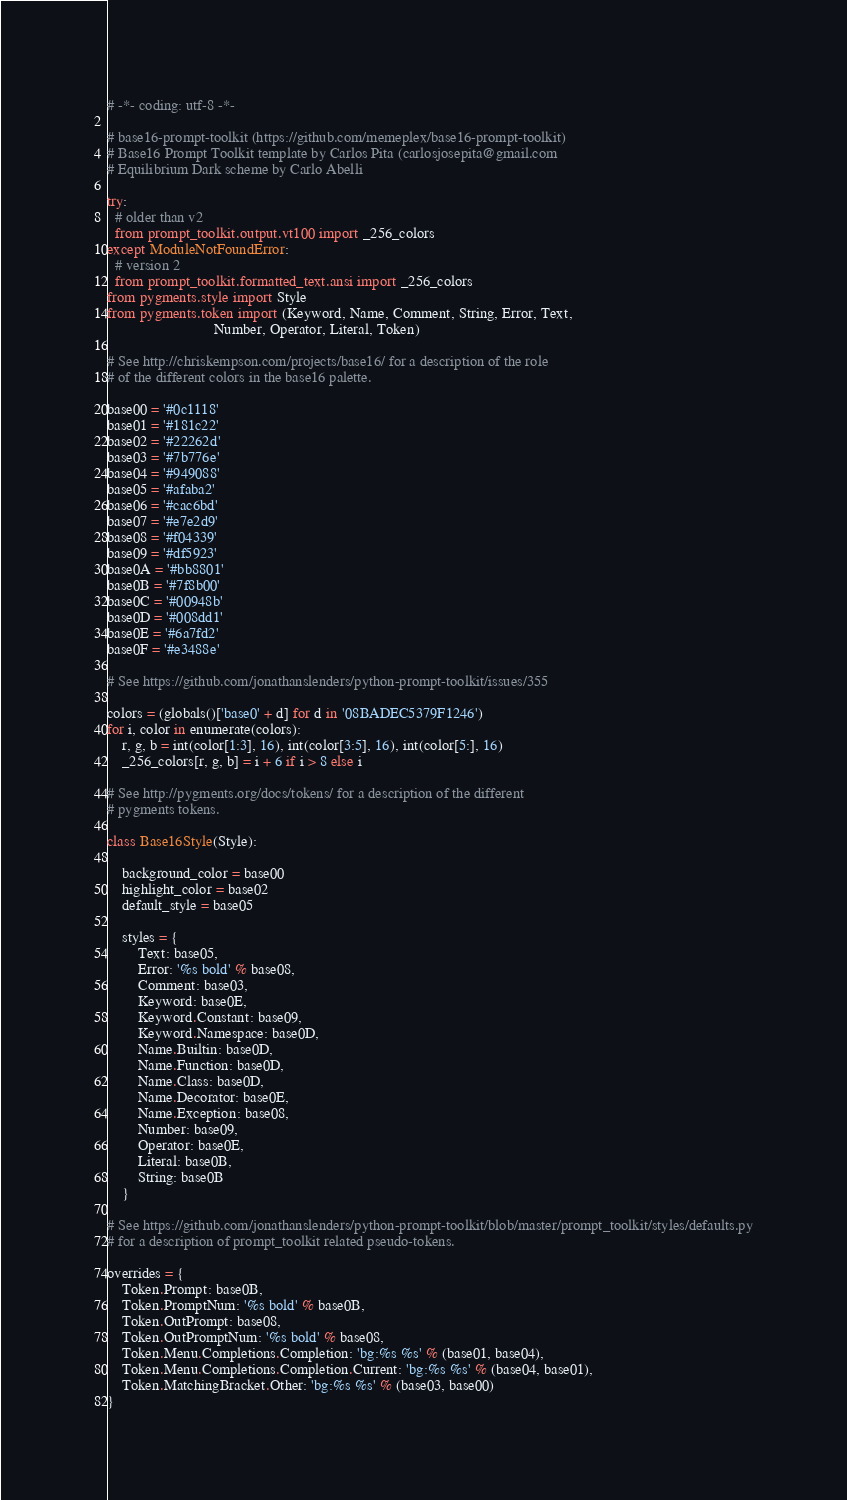<code> <loc_0><loc_0><loc_500><loc_500><_Python_># -*- coding: utf-8 -*-

# base16-prompt-toolkit (https://github.com/memeplex/base16-prompt-toolkit)
# Base16 Prompt Toolkit template by Carlos Pita (carlosjosepita@gmail.com
# Equilibrium Dark scheme by Carlo Abelli

try:
  # older than v2
  from prompt_toolkit.output.vt100 import _256_colors
except ModuleNotFoundError:
  # version 2
  from prompt_toolkit.formatted_text.ansi import _256_colors
from pygments.style import Style
from pygments.token import (Keyword, Name, Comment, String, Error, Text,
                            Number, Operator, Literal, Token)

# See http://chriskempson.com/projects/base16/ for a description of the role
# of the different colors in the base16 palette.

base00 = '#0c1118'
base01 = '#181c22'
base02 = '#22262d'
base03 = '#7b776e'
base04 = '#949088'
base05 = '#afaba2'
base06 = '#cac6bd'
base07 = '#e7e2d9'
base08 = '#f04339'
base09 = '#df5923'
base0A = '#bb8801'
base0B = '#7f8b00'
base0C = '#00948b'
base0D = '#008dd1'
base0E = '#6a7fd2'
base0F = '#e3488e'

# See https://github.com/jonathanslenders/python-prompt-toolkit/issues/355

colors = (globals()['base0' + d] for d in '08BADEC5379F1246')
for i, color in enumerate(colors):
    r, g, b = int(color[1:3], 16), int(color[3:5], 16), int(color[5:], 16)
    _256_colors[r, g, b] = i + 6 if i > 8 else i

# See http://pygments.org/docs/tokens/ for a description of the different
# pygments tokens.

class Base16Style(Style):

    background_color = base00
    highlight_color = base02
    default_style = base05

    styles = {
        Text: base05,
        Error: '%s bold' % base08,
        Comment: base03,
        Keyword: base0E,
        Keyword.Constant: base09,
        Keyword.Namespace: base0D,
        Name.Builtin: base0D,
        Name.Function: base0D,
        Name.Class: base0D,
        Name.Decorator: base0E,
        Name.Exception: base08,
        Number: base09,
        Operator: base0E,
        Literal: base0B,
        String: base0B
    }

# See https://github.com/jonathanslenders/python-prompt-toolkit/blob/master/prompt_toolkit/styles/defaults.py
# for a description of prompt_toolkit related pseudo-tokens.

overrides = {
    Token.Prompt: base0B,
    Token.PromptNum: '%s bold' % base0B,
    Token.OutPrompt: base08,
    Token.OutPromptNum: '%s bold' % base08,
    Token.Menu.Completions.Completion: 'bg:%s %s' % (base01, base04),
    Token.Menu.Completions.Completion.Current: 'bg:%s %s' % (base04, base01),
    Token.MatchingBracket.Other: 'bg:%s %s' % (base03, base00)
}
</code> 